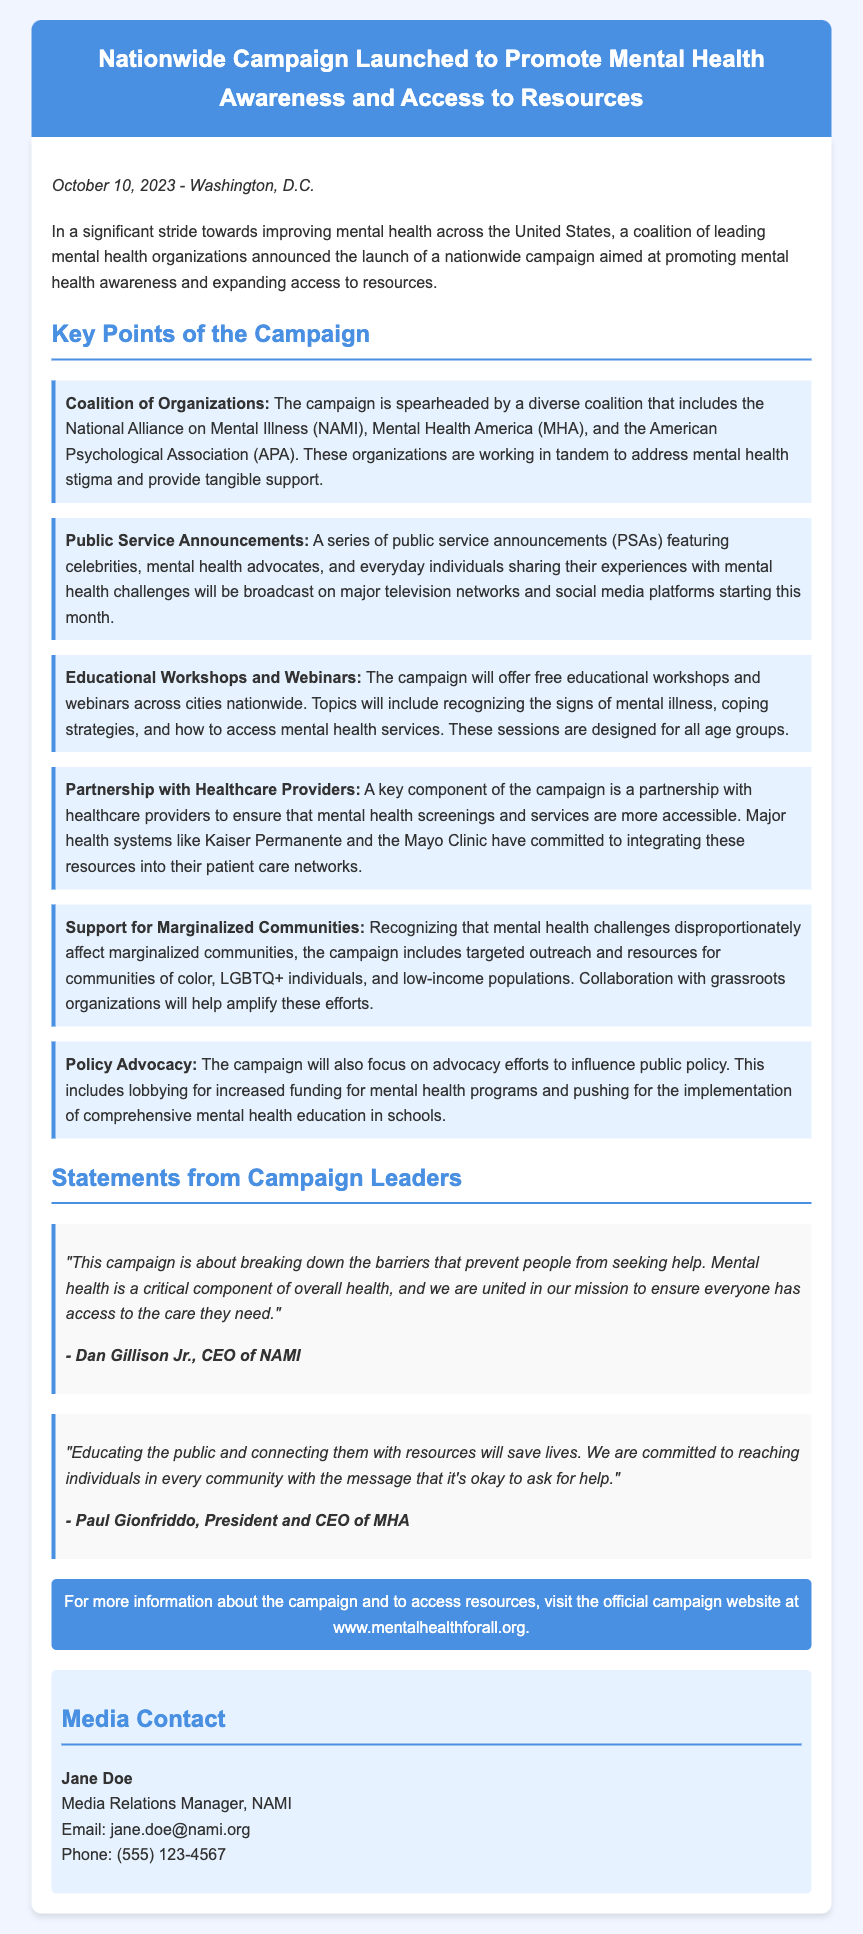What is the date of the press release? The date of the press release is explicitly mentioned at the beginning of the document.
Answer: October 10, 2023 Who are the leading organizations involved in the campaign? The document lists the key organizations leading the campaign collectively.
Answer: NAMI, MHA, APA What type of announcements will be featured in the campaign? The document specifies the nature of the announcements that will be broadcasted as part of the campaign.
Answer: Public Service Announcements What specific kind of workshops will the campaign offer? The document details the offerings under the campaign, specifying what type of educational events will be available.
Answer: Educational Workshops and Webinars Which populations will receive targeted outreach? The document highlights specific communities that will have focused efforts in the campaign.
Answer: Marginalized communities What is the campaign’s focus on public policy? The document outlines specific activities the campaign will engage in related to legal and financial frameworks.
Answer: Policy Advocacy How can someone access more information about the campaign? The document provides a clear direction on where to find additional details about the campaign.
Answer: www.mentalhealthforall.org Who is the media contact for the campaign? The document includes contact information for media inquiries, providing the name of the person responsible.
Answer: Jane Doe What quote did Dan Gillison Jr. provide? The document features a specific quote attributed to Dan Gillison Jr. related to the campaign's mission.
Answer: "This campaign is about breaking down the barriers that prevent people from seeking help." 